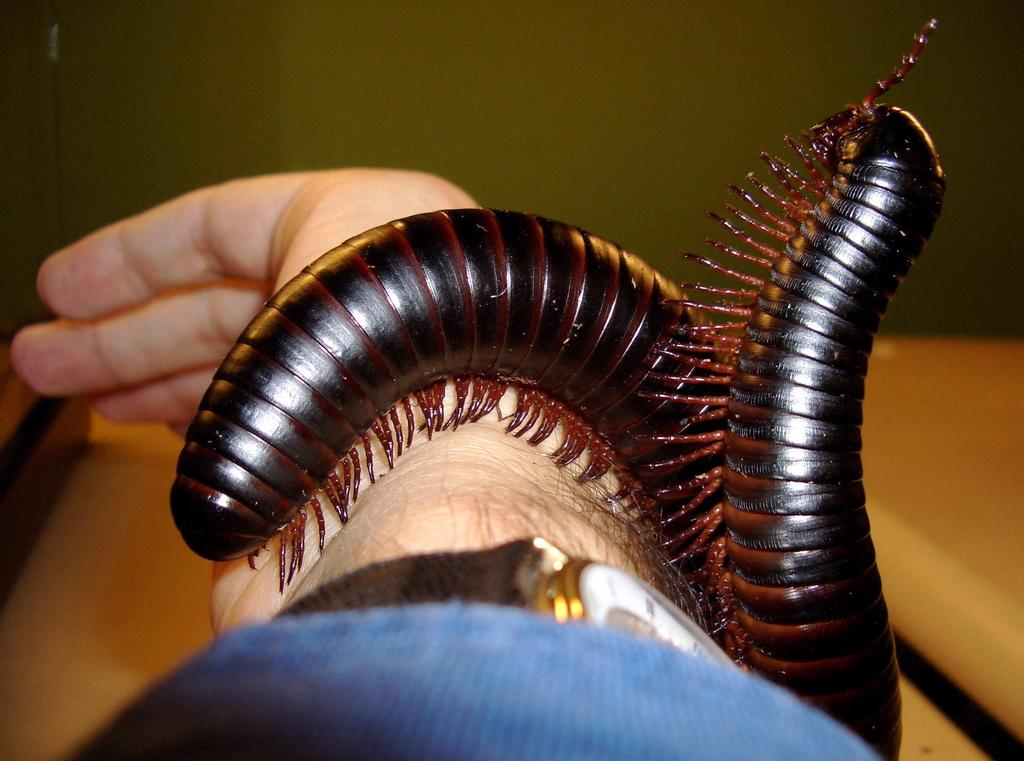What is the main subject of the image? The main subject of the image is a hand. What is present on the hand in the image? There are insects on the hand in the image. Can you describe the background of the image? The background of the image is blurred. What type of interest does the actor have in the twig in the image? There is no actor or twig present in the image. 